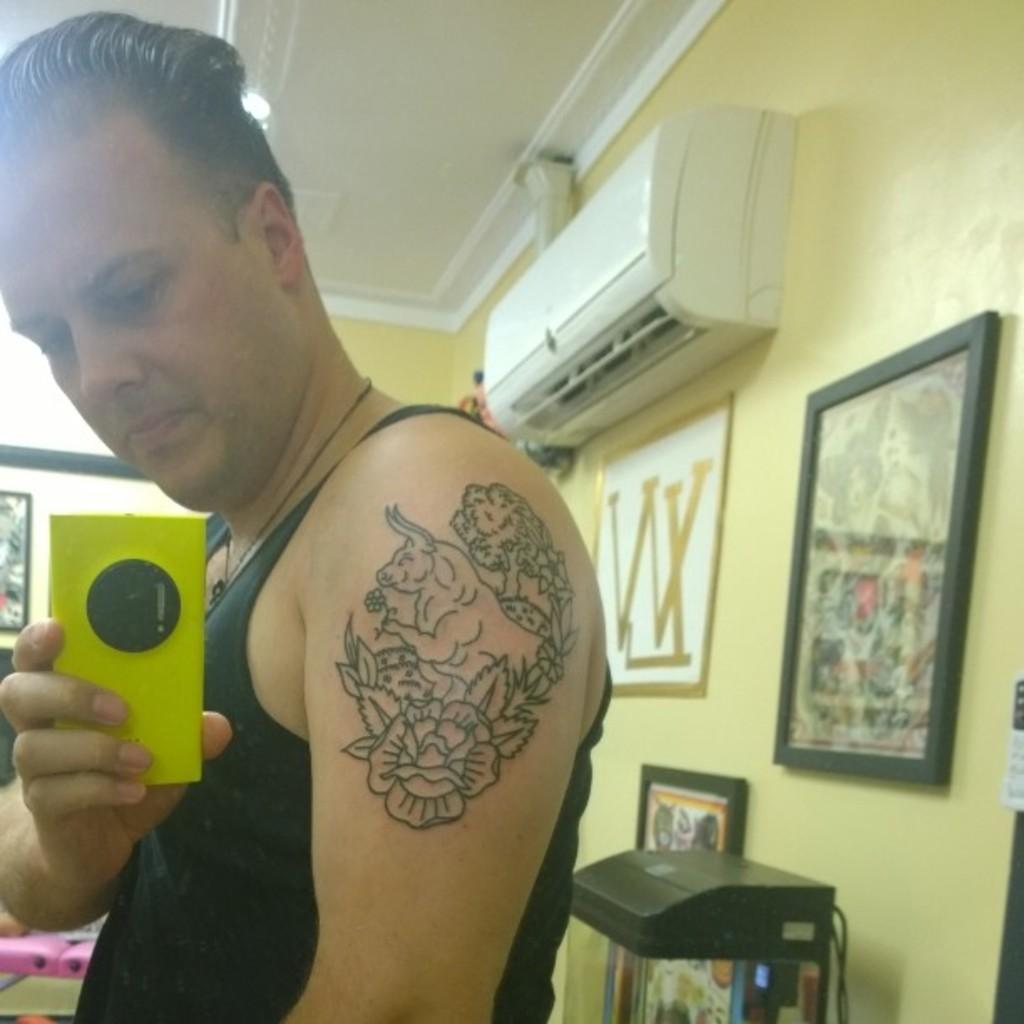Could you give a brief overview of what you see in this image? This picture shows about a man taking a photo with the yellow phone and showing the tattoo. Behind there is a yellow wall with many photo frames and ac unit. 